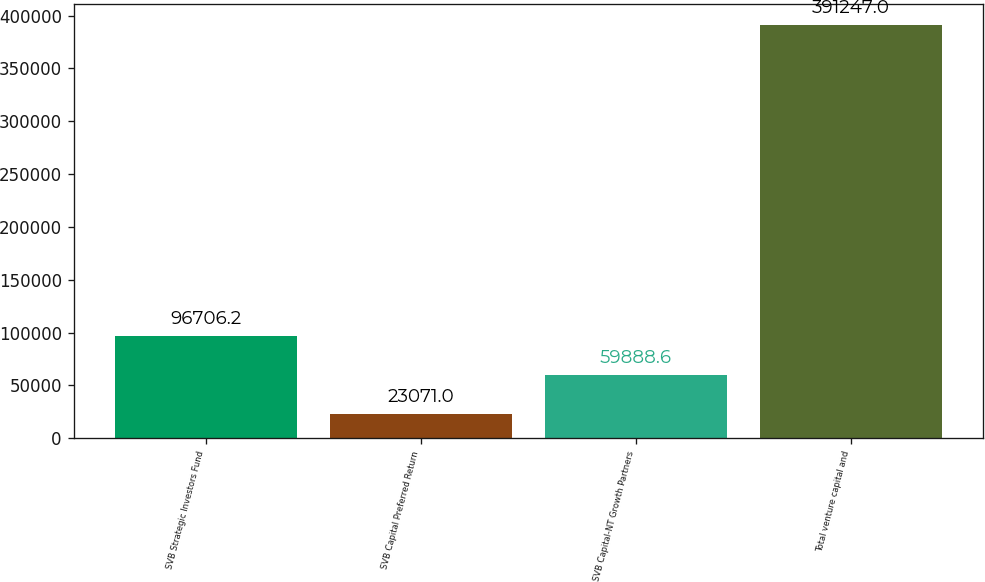<chart> <loc_0><loc_0><loc_500><loc_500><bar_chart><fcel>SVB Strategic Investors Fund<fcel>SVB Capital Preferred Return<fcel>SVB Capital-NT Growth Partners<fcel>Total venture capital and<nl><fcel>96706.2<fcel>23071<fcel>59888.6<fcel>391247<nl></chart> 